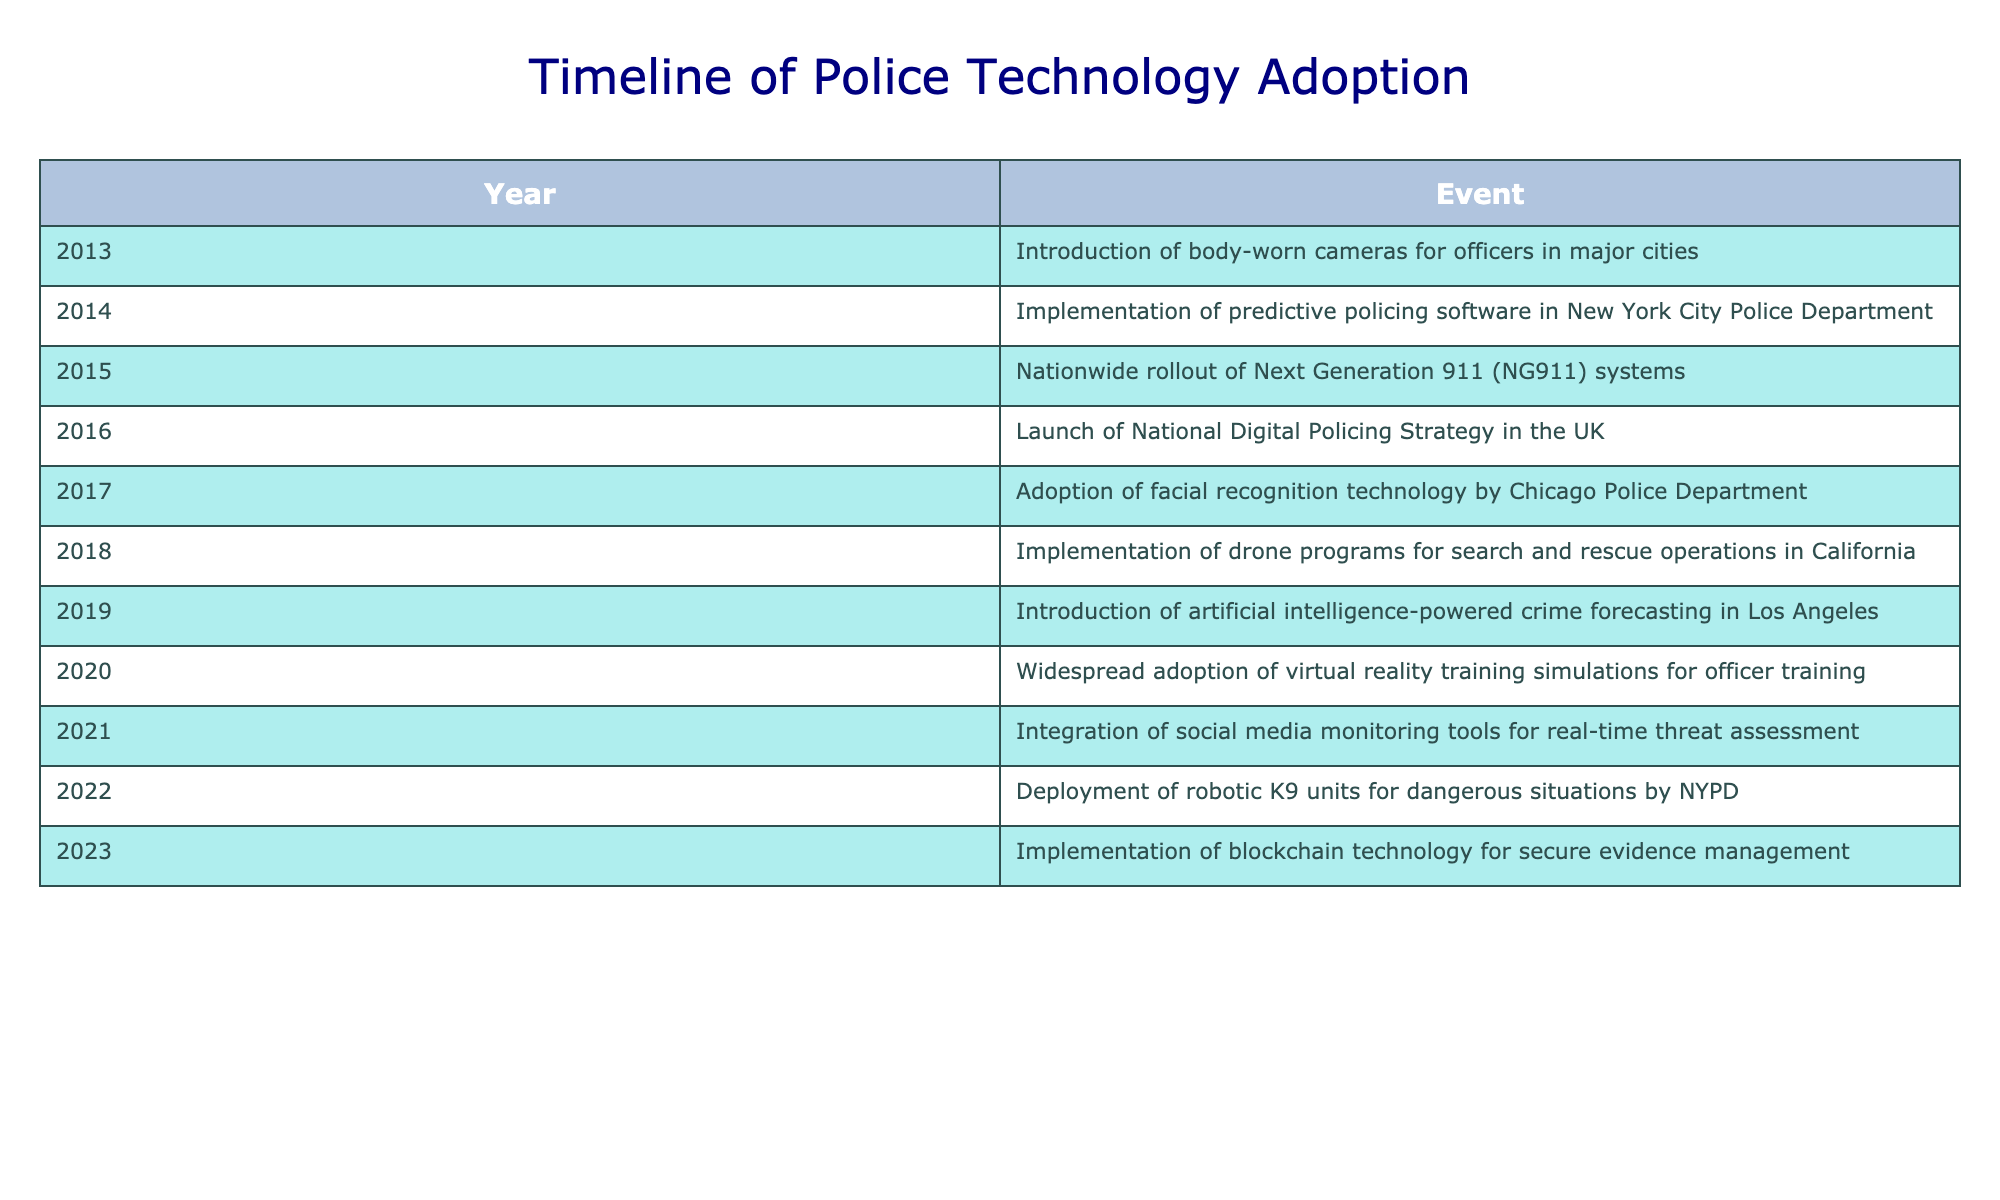What year did the NYPD deploy robotic K9 units? The table lists the deployment of robotic K9 units by NYPD as occurring in the year 2022. Thus, by directly referencing this row, the answer is clear.
Answer: 2022 What technology was adopted by the Chicago Police Department in 2017? From the table, the event related to the Chicago Police Department in 2017 indicates the adoption of facial recognition technology. This can be directly identified from the corresponding entry.
Answer: Facial recognition technology How many years passed between the introduction of body-worn cameras and the implementation of blockchain technology? The introduction of body-worn cameras was in 2013, and blockchain technology implementation was in 2023. Subtracting the earlier year from the later year: 2023 - 2013 = 10 years. Therefore, ten years lapsed between these two events.
Answer: 10 years Did the implementation of predictive policing software happen before or after the rollout of Next Generation 911 systems? The table shows that predictive policing software was implemented in 2014 and Next Generation 911 systems were rolled out in 2015. Since 2014 is before 2015, this means the predictive policing software was implemented first.
Answer: Before What are the total number of unique events listed in the table? Counting each row in the timeline of events, there are 11 distinct entries, each corresponding to a year and an associated technological milestone. Thus, the total number of unique events listed is 11.
Answer: 11 Which two years saw the introduction of new technologies related to training? In the table, virtual reality training simulations for officer training were adopted in 2020, while the launch of the National Digital Policing Strategy, although not solely a training initiative, also impacted training methods in 2016.  Thus, there are two relevant years: 2020 and 2016.
Answer: 2020, 2016 What is the latest technological advancement listed in the table? The table indicates that the latest technological advancement is the implementation of blockchain technology for secure evidence management, which occurred in 2023. To find the most recent event, we look at the year's column for the maximum value.
Answer: 2023 How many technologies were related to public safety increase, such as AI and drones? In the entries, the implementation of artificial intelligence-powered crime forecasting (2019) and drone programs for search and rescue operations (2018) clearly show initiatives aimed at enhancing public safety. Thus, there are two distinct technologies listed that relate directly to public safety.
Answer: 2 